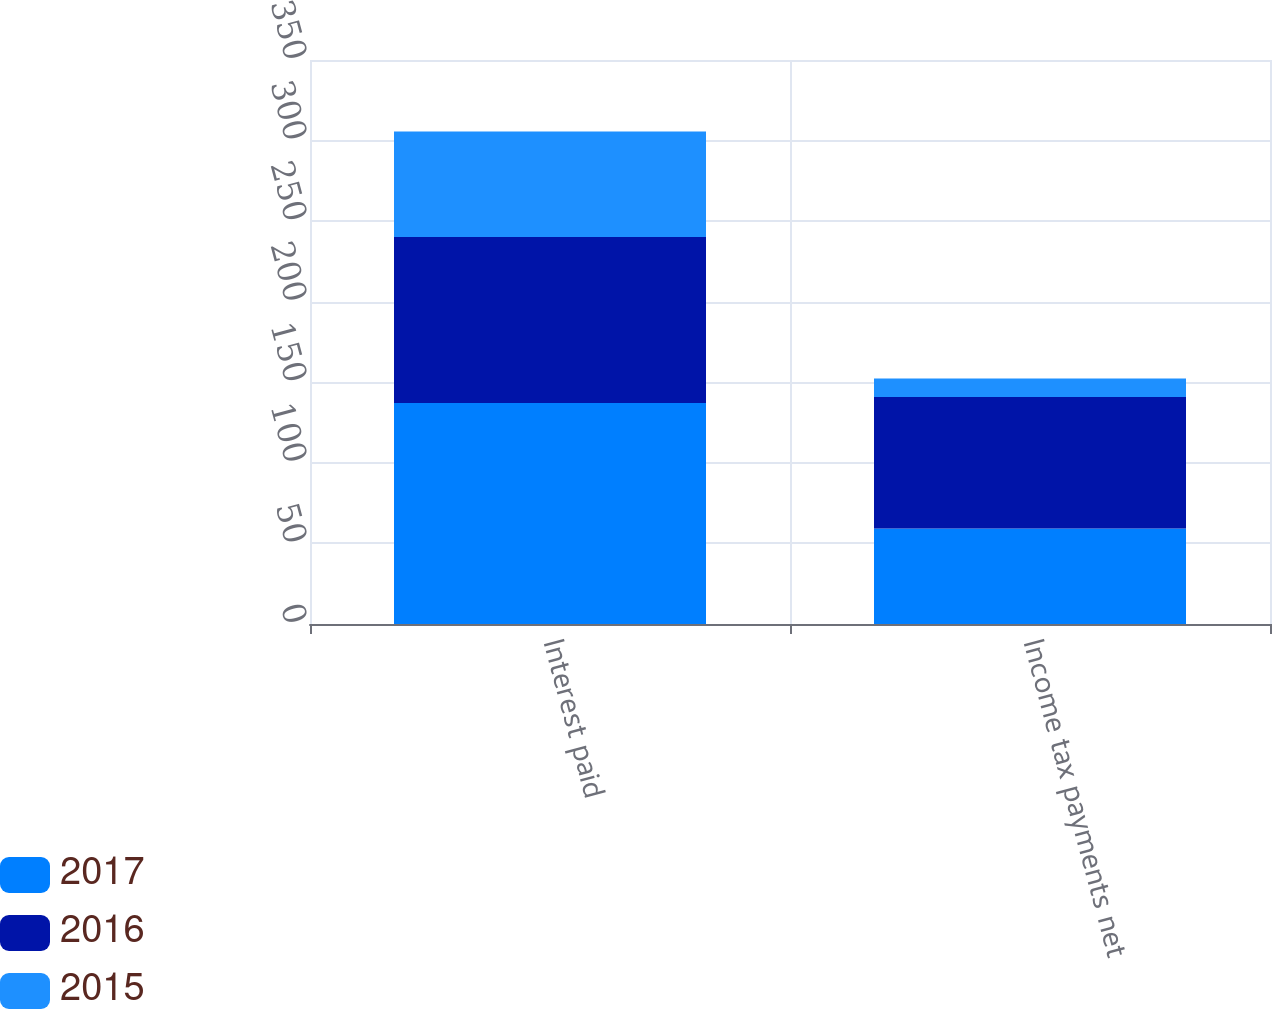Convert chart. <chart><loc_0><loc_0><loc_500><loc_500><stacked_bar_chart><ecel><fcel>Interest paid<fcel>Income tax payments net<nl><fcel>2017<fcel>137.2<fcel>59.3<nl><fcel>2016<fcel>103<fcel>81.5<nl><fcel>2015<fcel>65.4<fcel>11.5<nl></chart> 